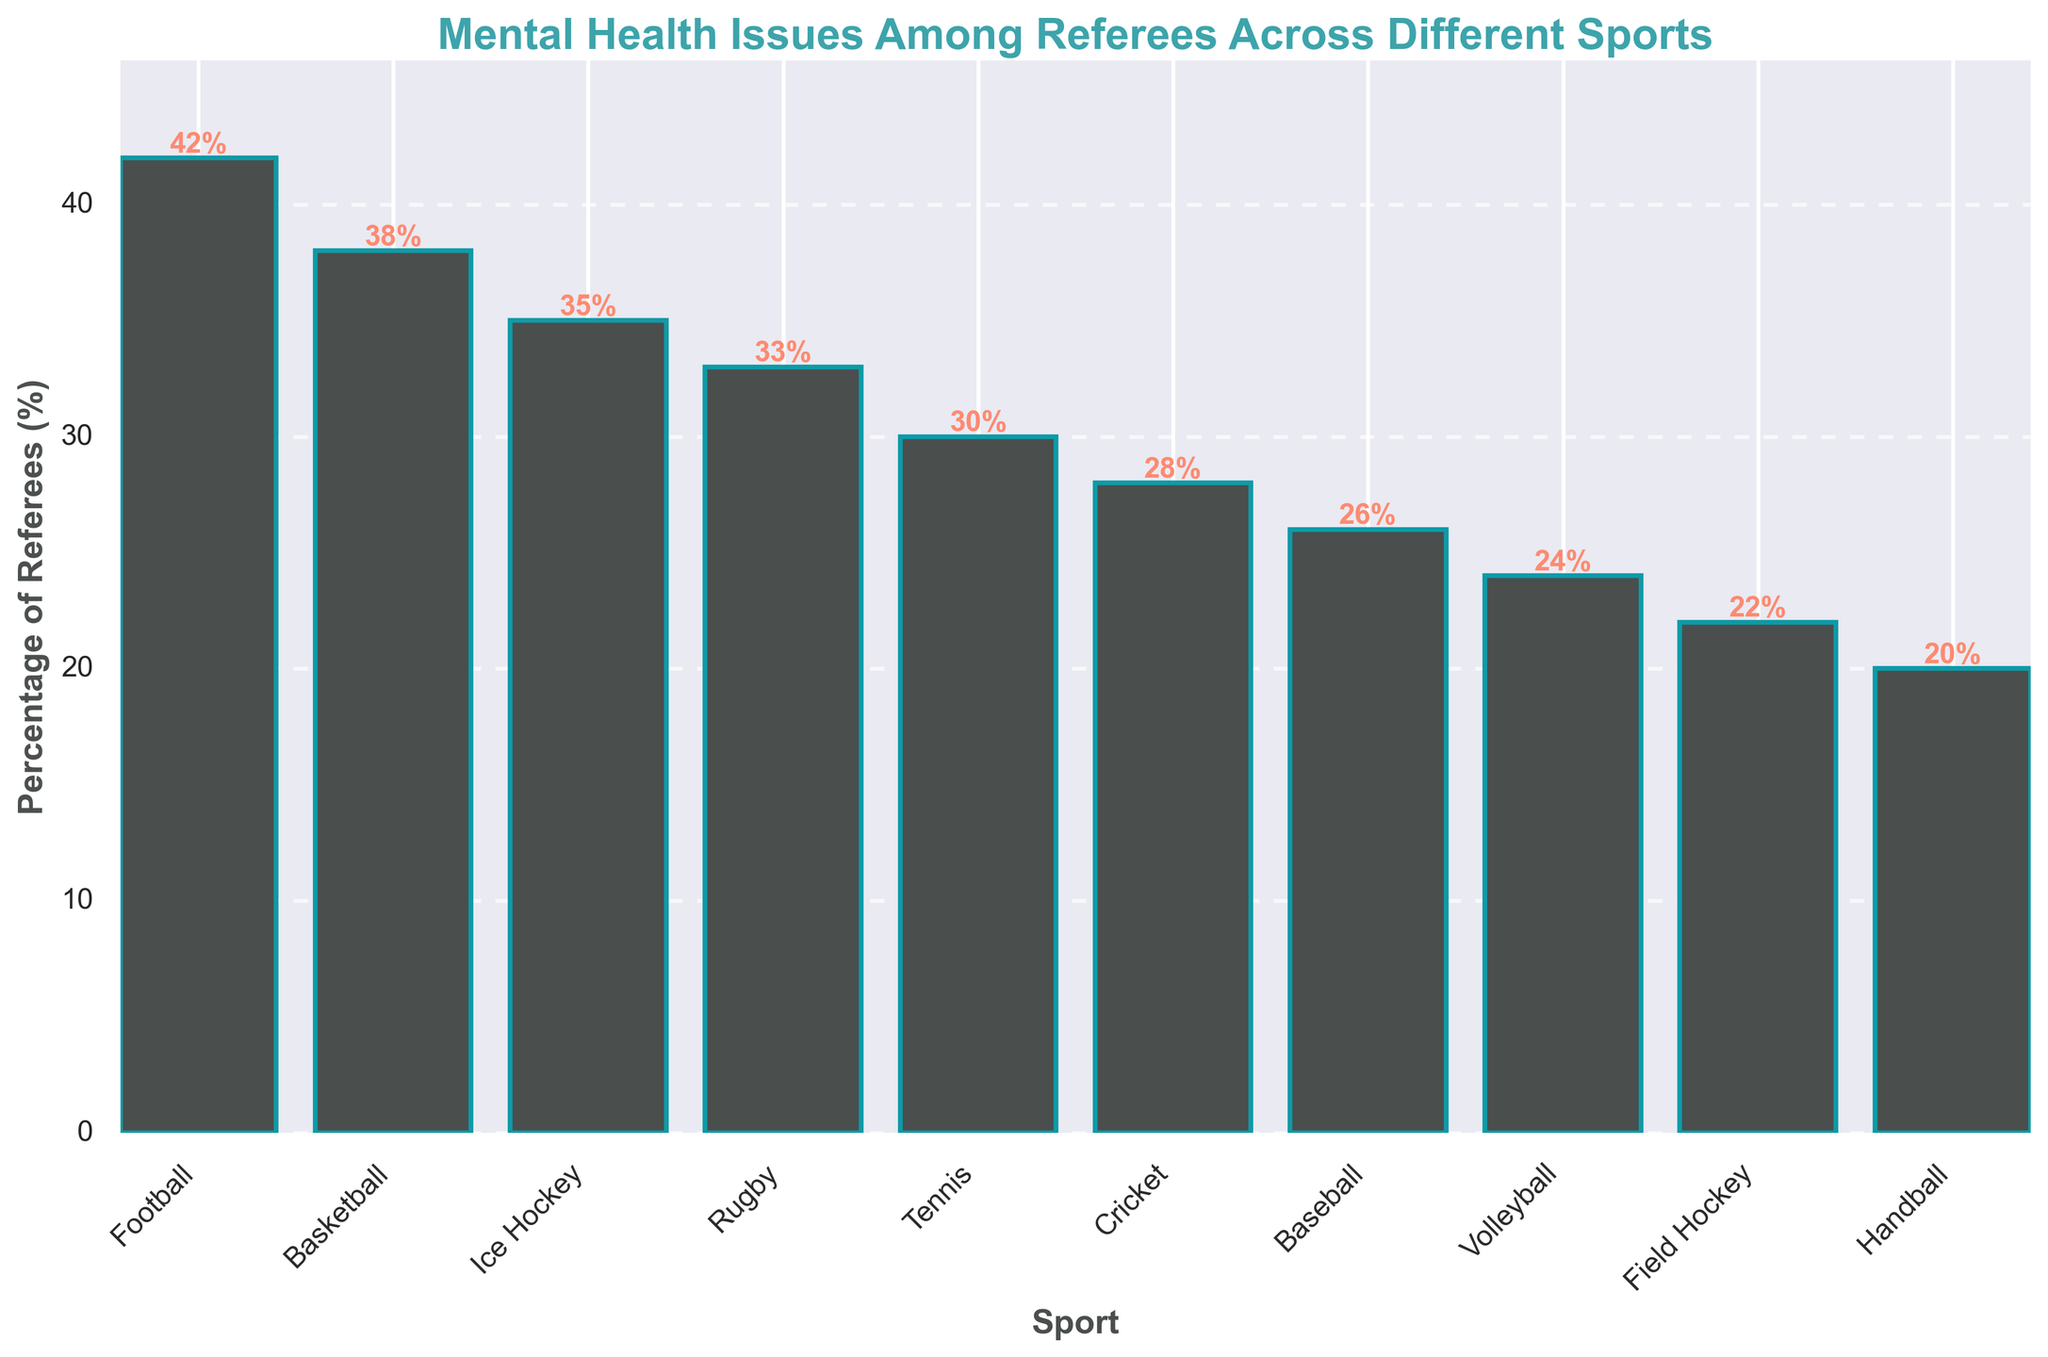Which sport has the highest percentage of referees reporting mental health issues? Look at the bar with the greatest height. Football is at 42%.
Answer: Football Which two sports have the same difference in the percentage of referees reporting mental health issues? Calculate the differences between all pairs and identify which are equal. For example, Football (42%) and Tennis (30%) have a difference of 12. Similarly, Rugby (33%) and Baseball (26%) also have a difference of 7.
Answer: Football and Tennis What is the average percentage of referees reporting mental health issues among Basketball, Ice Hockey, and Rugby? Sum the percentages of the three sports: Basketball (38%) + Ice Hockey (35%) + Rugby (33%) = 106. Then divide by 3: 106/3 = 35.33.
Answer: 35.33% Which sport has the smallest percentage of referees reporting mental health issues? Look at the bar with the shortest height. Handball is at 20%.
Answer: Handball What is the total percentage of referees reporting mental health issues for Football, Basketball, and Ice Hockey combined? Sum the percentages for these sports: Football (42%) + Basketball (38%) + Ice Hockey (35%) = 115.
Answer: 115% By how much does the percentage of referees reporting mental health issues in Football exceed that in Field Hockey? Subtract Field Hockey's percentage (22%) from Football's (42%): 42 - 22 = 20.
Answer: 20 Which sport shows a smaller percentage of referees reporting mental health issues compared to Volleyball but larger than Handball? Identify bars between 20% (Handball) and 24% (Volleyball). Field Hockey is at 22%.
Answer: Field Hockey What is the difference in the percentage of referees reporting mental health issues between the sport with the highest and the sport with the lowest percentage? Subtract Handball (20%) from Football (42%): 42 - 20 = 22.
Answer: 22 What is the ratio of referees reporting mental health issues in Football to those in Cricket? Divide Football's percentage (42%) by Cricket's (28%): 42/28 = 1.5.
Answer: 1.5 Which sport shows a lower percentage of referees reporting mental health issues, Tennis or Rugby? Compare the percentages of Tennis (30%) and Rugby (33%). Tennis is lower.
Answer: Tennis 